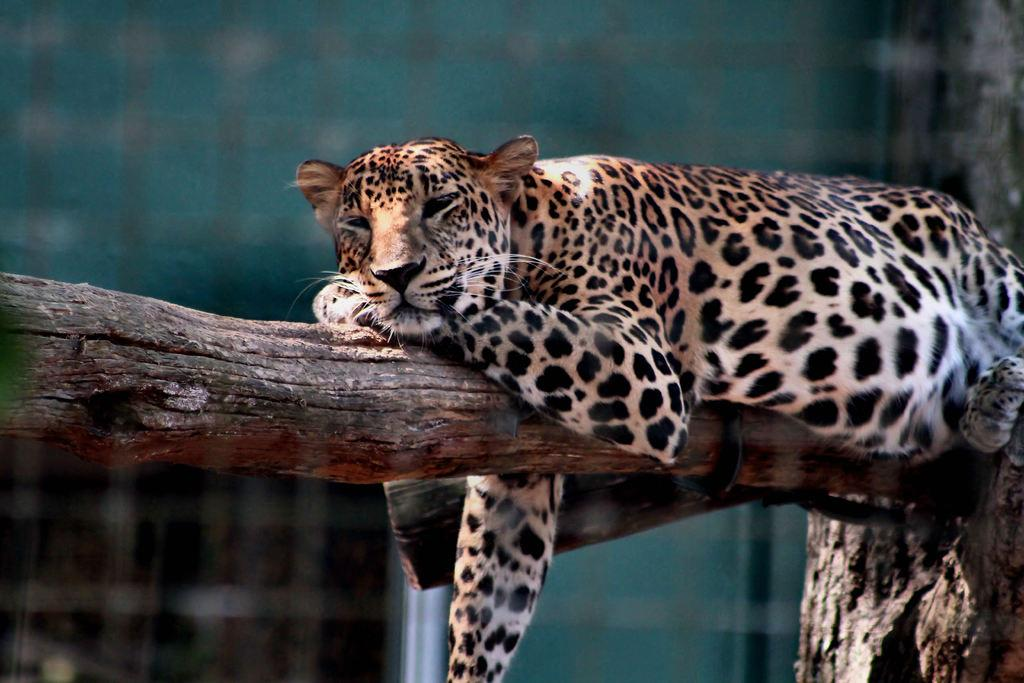What animal is the main subject of the image? There is a cheetah in the image. Where is the cheetah located in the image? The cheetah is lying on a branch. What type of cheese is the cheetah eating in the image? There is no cheese present in the image; the cheetah is lying on a branch. What kind of pot is visible in the image? There is no pot present in the image; the main subject is a cheetah lying on a branch. 